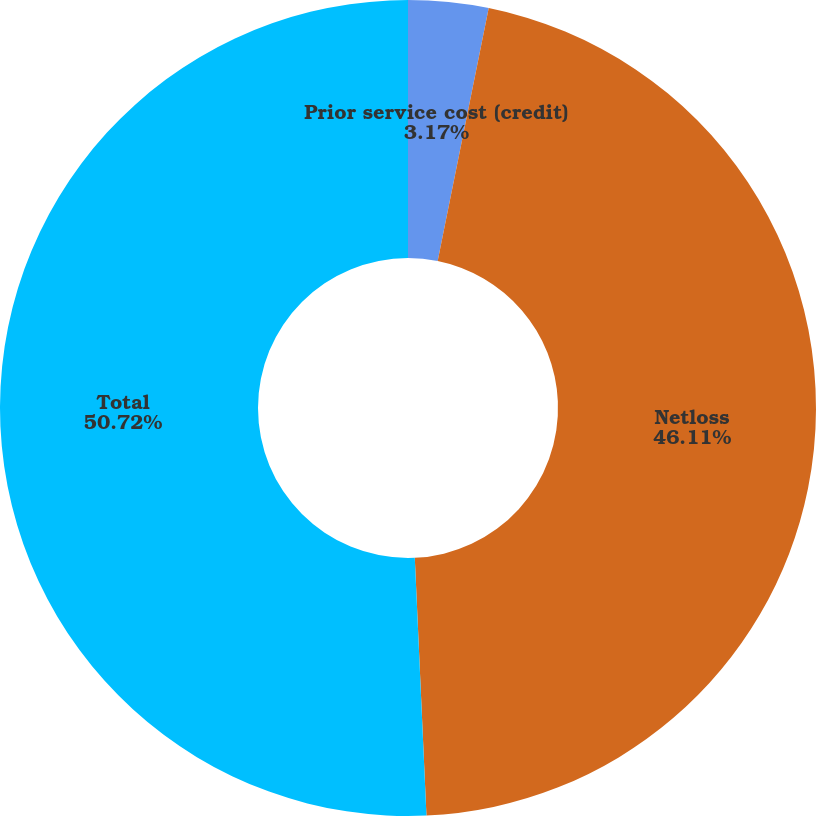Convert chart to OTSL. <chart><loc_0><loc_0><loc_500><loc_500><pie_chart><fcel>Prior service cost (credit)<fcel>Netloss<fcel>Total<nl><fcel>3.17%<fcel>46.11%<fcel>50.72%<nl></chart> 